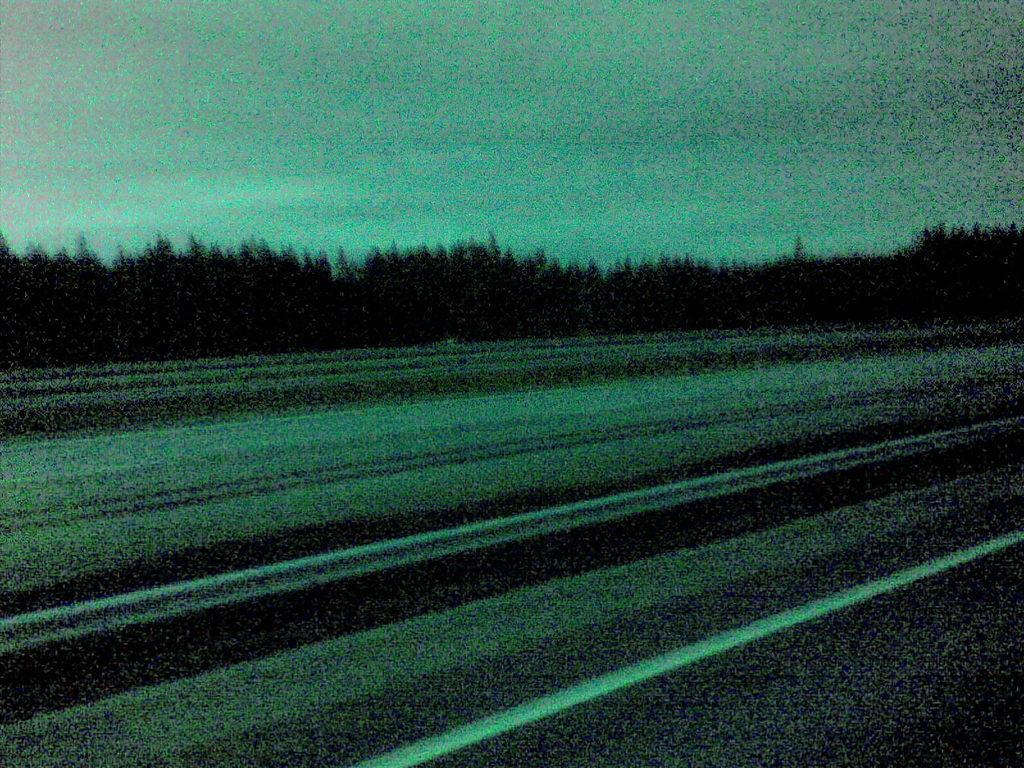Could you give a brief overview of what you see in this image? In this picture we can observe a road. In the background there are trees. We can observe a sky here. 